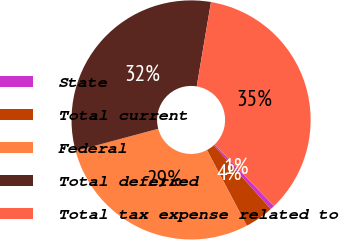Convert chart. <chart><loc_0><loc_0><loc_500><loc_500><pie_chart><fcel>State<fcel>Total current<fcel>Federal<fcel>Total deferred<fcel>Total tax expense related to<nl><fcel>0.59%<fcel>3.89%<fcel>28.54%<fcel>31.84%<fcel>35.14%<nl></chart> 